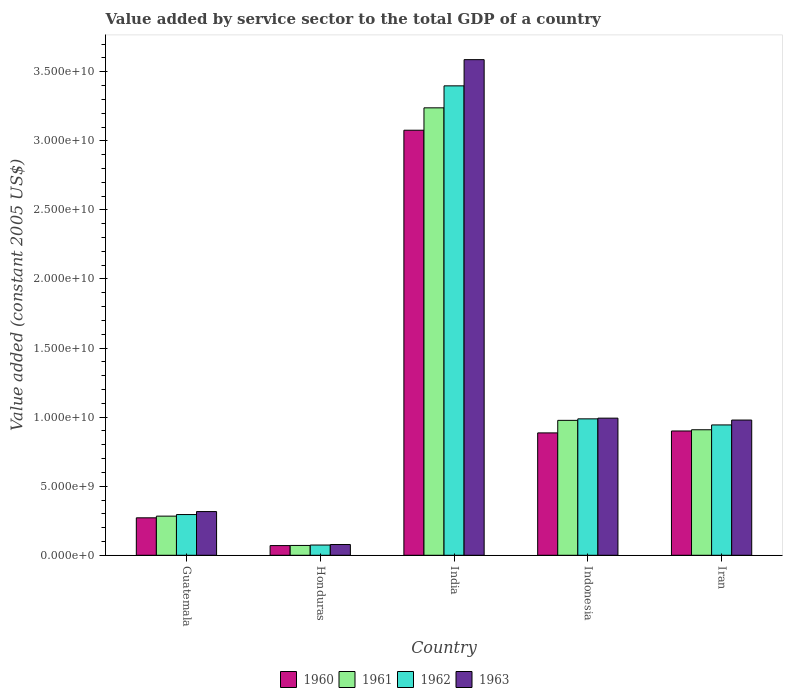How many different coloured bars are there?
Ensure brevity in your answer.  4. How many groups of bars are there?
Give a very brief answer. 5. Are the number of bars per tick equal to the number of legend labels?
Ensure brevity in your answer.  Yes. How many bars are there on the 2nd tick from the right?
Offer a terse response. 4. What is the label of the 5th group of bars from the left?
Provide a succinct answer. Iran. What is the value added by service sector in 1963 in Honduras?
Ensure brevity in your answer.  7.78e+08. Across all countries, what is the maximum value added by service sector in 1963?
Offer a very short reply. 3.59e+1. Across all countries, what is the minimum value added by service sector in 1960?
Offer a terse response. 7.01e+08. In which country was the value added by service sector in 1961 maximum?
Ensure brevity in your answer.  India. In which country was the value added by service sector in 1961 minimum?
Keep it short and to the point. Honduras. What is the total value added by service sector in 1961 in the graph?
Your response must be concise. 5.48e+1. What is the difference between the value added by service sector in 1961 in Indonesia and that in Iran?
Provide a short and direct response. 6.80e+08. What is the difference between the value added by service sector in 1963 in India and the value added by service sector in 1960 in Guatemala?
Ensure brevity in your answer.  3.32e+1. What is the average value added by service sector in 1960 per country?
Your answer should be very brief. 1.04e+1. What is the difference between the value added by service sector of/in 1963 and value added by service sector of/in 1960 in Iran?
Provide a short and direct response. 7.91e+08. What is the ratio of the value added by service sector in 1962 in Guatemala to that in Indonesia?
Offer a very short reply. 0.3. What is the difference between the highest and the second highest value added by service sector in 1961?
Keep it short and to the point. 2.26e+1. What is the difference between the highest and the lowest value added by service sector in 1960?
Ensure brevity in your answer.  3.01e+1. In how many countries, is the value added by service sector in 1961 greater than the average value added by service sector in 1961 taken over all countries?
Give a very brief answer. 1. Is it the case that in every country, the sum of the value added by service sector in 1960 and value added by service sector in 1963 is greater than the sum of value added by service sector in 1961 and value added by service sector in 1962?
Make the answer very short. No. What does the 1st bar from the left in Guatemala represents?
Give a very brief answer. 1960. Are the values on the major ticks of Y-axis written in scientific E-notation?
Offer a terse response. Yes. Does the graph contain any zero values?
Make the answer very short. No. Does the graph contain grids?
Provide a short and direct response. No. Where does the legend appear in the graph?
Offer a very short reply. Bottom center. How are the legend labels stacked?
Your response must be concise. Horizontal. What is the title of the graph?
Your response must be concise. Value added by service sector to the total GDP of a country. What is the label or title of the X-axis?
Your answer should be compact. Country. What is the label or title of the Y-axis?
Make the answer very short. Value added (constant 2005 US$). What is the Value added (constant 2005 US$) of 1960 in Guatemala?
Offer a terse response. 2.71e+09. What is the Value added (constant 2005 US$) of 1961 in Guatemala?
Your answer should be compact. 2.83e+09. What is the Value added (constant 2005 US$) of 1962 in Guatemala?
Your answer should be compact. 2.95e+09. What is the Value added (constant 2005 US$) of 1963 in Guatemala?
Your answer should be compact. 3.16e+09. What is the Value added (constant 2005 US$) in 1960 in Honduras?
Ensure brevity in your answer.  7.01e+08. What is the Value added (constant 2005 US$) of 1961 in Honduras?
Your answer should be compact. 7.12e+08. What is the Value added (constant 2005 US$) of 1962 in Honduras?
Keep it short and to the point. 7.41e+08. What is the Value added (constant 2005 US$) of 1963 in Honduras?
Make the answer very short. 7.78e+08. What is the Value added (constant 2005 US$) of 1960 in India?
Give a very brief answer. 3.08e+1. What is the Value added (constant 2005 US$) of 1961 in India?
Make the answer very short. 3.24e+1. What is the Value added (constant 2005 US$) of 1962 in India?
Provide a short and direct response. 3.40e+1. What is the Value added (constant 2005 US$) of 1963 in India?
Provide a succinct answer. 3.59e+1. What is the Value added (constant 2005 US$) in 1960 in Indonesia?
Offer a terse response. 8.86e+09. What is the Value added (constant 2005 US$) of 1961 in Indonesia?
Keep it short and to the point. 9.77e+09. What is the Value added (constant 2005 US$) of 1962 in Indonesia?
Ensure brevity in your answer.  9.88e+09. What is the Value added (constant 2005 US$) of 1963 in Indonesia?
Offer a very short reply. 9.93e+09. What is the Value added (constant 2005 US$) of 1960 in Iran?
Make the answer very short. 9.00e+09. What is the Value added (constant 2005 US$) in 1961 in Iran?
Offer a terse response. 9.09e+09. What is the Value added (constant 2005 US$) in 1962 in Iran?
Make the answer very short. 9.44e+09. What is the Value added (constant 2005 US$) of 1963 in Iran?
Ensure brevity in your answer.  9.79e+09. Across all countries, what is the maximum Value added (constant 2005 US$) of 1960?
Offer a terse response. 3.08e+1. Across all countries, what is the maximum Value added (constant 2005 US$) in 1961?
Keep it short and to the point. 3.24e+1. Across all countries, what is the maximum Value added (constant 2005 US$) of 1962?
Give a very brief answer. 3.40e+1. Across all countries, what is the maximum Value added (constant 2005 US$) of 1963?
Ensure brevity in your answer.  3.59e+1. Across all countries, what is the minimum Value added (constant 2005 US$) in 1960?
Your answer should be very brief. 7.01e+08. Across all countries, what is the minimum Value added (constant 2005 US$) of 1961?
Give a very brief answer. 7.12e+08. Across all countries, what is the minimum Value added (constant 2005 US$) of 1962?
Provide a short and direct response. 7.41e+08. Across all countries, what is the minimum Value added (constant 2005 US$) of 1963?
Your answer should be compact. 7.78e+08. What is the total Value added (constant 2005 US$) in 1960 in the graph?
Keep it short and to the point. 5.20e+1. What is the total Value added (constant 2005 US$) in 1961 in the graph?
Offer a terse response. 5.48e+1. What is the total Value added (constant 2005 US$) in 1962 in the graph?
Your answer should be very brief. 5.70e+1. What is the total Value added (constant 2005 US$) of 1963 in the graph?
Your answer should be compact. 5.95e+1. What is the difference between the Value added (constant 2005 US$) in 1960 in Guatemala and that in Honduras?
Provide a short and direct response. 2.01e+09. What is the difference between the Value added (constant 2005 US$) in 1961 in Guatemala and that in Honduras?
Offer a terse response. 2.12e+09. What is the difference between the Value added (constant 2005 US$) of 1962 in Guatemala and that in Honduras?
Give a very brief answer. 2.21e+09. What is the difference between the Value added (constant 2005 US$) of 1963 in Guatemala and that in Honduras?
Provide a short and direct response. 2.39e+09. What is the difference between the Value added (constant 2005 US$) in 1960 in Guatemala and that in India?
Make the answer very short. -2.81e+1. What is the difference between the Value added (constant 2005 US$) in 1961 in Guatemala and that in India?
Your response must be concise. -2.96e+1. What is the difference between the Value added (constant 2005 US$) in 1962 in Guatemala and that in India?
Provide a succinct answer. -3.10e+1. What is the difference between the Value added (constant 2005 US$) of 1963 in Guatemala and that in India?
Your response must be concise. -3.27e+1. What is the difference between the Value added (constant 2005 US$) in 1960 in Guatemala and that in Indonesia?
Your answer should be compact. -6.15e+09. What is the difference between the Value added (constant 2005 US$) in 1961 in Guatemala and that in Indonesia?
Provide a succinct answer. -6.93e+09. What is the difference between the Value added (constant 2005 US$) of 1962 in Guatemala and that in Indonesia?
Provide a succinct answer. -6.93e+09. What is the difference between the Value added (constant 2005 US$) in 1963 in Guatemala and that in Indonesia?
Provide a short and direct response. -6.76e+09. What is the difference between the Value added (constant 2005 US$) in 1960 in Guatemala and that in Iran?
Offer a very short reply. -6.29e+09. What is the difference between the Value added (constant 2005 US$) of 1961 in Guatemala and that in Iran?
Provide a short and direct response. -6.25e+09. What is the difference between the Value added (constant 2005 US$) in 1962 in Guatemala and that in Iran?
Your answer should be compact. -6.49e+09. What is the difference between the Value added (constant 2005 US$) of 1963 in Guatemala and that in Iran?
Your answer should be compact. -6.62e+09. What is the difference between the Value added (constant 2005 US$) of 1960 in Honduras and that in India?
Keep it short and to the point. -3.01e+1. What is the difference between the Value added (constant 2005 US$) in 1961 in Honduras and that in India?
Provide a short and direct response. -3.17e+1. What is the difference between the Value added (constant 2005 US$) of 1962 in Honduras and that in India?
Make the answer very short. -3.32e+1. What is the difference between the Value added (constant 2005 US$) of 1963 in Honduras and that in India?
Ensure brevity in your answer.  -3.51e+1. What is the difference between the Value added (constant 2005 US$) in 1960 in Honduras and that in Indonesia?
Make the answer very short. -8.16e+09. What is the difference between the Value added (constant 2005 US$) in 1961 in Honduras and that in Indonesia?
Provide a short and direct response. -9.05e+09. What is the difference between the Value added (constant 2005 US$) of 1962 in Honduras and that in Indonesia?
Give a very brief answer. -9.13e+09. What is the difference between the Value added (constant 2005 US$) of 1963 in Honduras and that in Indonesia?
Make the answer very short. -9.15e+09. What is the difference between the Value added (constant 2005 US$) of 1960 in Honduras and that in Iran?
Your answer should be compact. -8.30e+09. What is the difference between the Value added (constant 2005 US$) in 1961 in Honduras and that in Iran?
Keep it short and to the point. -8.37e+09. What is the difference between the Value added (constant 2005 US$) of 1962 in Honduras and that in Iran?
Your answer should be compact. -8.70e+09. What is the difference between the Value added (constant 2005 US$) in 1963 in Honduras and that in Iran?
Provide a short and direct response. -9.01e+09. What is the difference between the Value added (constant 2005 US$) of 1960 in India and that in Indonesia?
Offer a terse response. 2.19e+1. What is the difference between the Value added (constant 2005 US$) in 1961 in India and that in Indonesia?
Make the answer very short. 2.26e+1. What is the difference between the Value added (constant 2005 US$) in 1962 in India and that in Indonesia?
Offer a very short reply. 2.41e+1. What is the difference between the Value added (constant 2005 US$) in 1963 in India and that in Indonesia?
Offer a very short reply. 2.60e+1. What is the difference between the Value added (constant 2005 US$) in 1960 in India and that in Iran?
Offer a very short reply. 2.18e+1. What is the difference between the Value added (constant 2005 US$) in 1961 in India and that in Iran?
Your response must be concise. 2.33e+1. What is the difference between the Value added (constant 2005 US$) in 1962 in India and that in Iran?
Provide a succinct answer. 2.45e+1. What is the difference between the Value added (constant 2005 US$) in 1963 in India and that in Iran?
Your answer should be compact. 2.61e+1. What is the difference between the Value added (constant 2005 US$) of 1960 in Indonesia and that in Iran?
Keep it short and to the point. -1.39e+08. What is the difference between the Value added (constant 2005 US$) in 1961 in Indonesia and that in Iran?
Ensure brevity in your answer.  6.80e+08. What is the difference between the Value added (constant 2005 US$) in 1962 in Indonesia and that in Iran?
Give a very brief answer. 4.39e+08. What is the difference between the Value added (constant 2005 US$) in 1963 in Indonesia and that in Iran?
Keep it short and to the point. 1.38e+08. What is the difference between the Value added (constant 2005 US$) of 1960 in Guatemala and the Value added (constant 2005 US$) of 1961 in Honduras?
Keep it short and to the point. 2.00e+09. What is the difference between the Value added (constant 2005 US$) of 1960 in Guatemala and the Value added (constant 2005 US$) of 1962 in Honduras?
Provide a succinct answer. 1.97e+09. What is the difference between the Value added (constant 2005 US$) of 1960 in Guatemala and the Value added (constant 2005 US$) of 1963 in Honduras?
Ensure brevity in your answer.  1.93e+09. What is the difference between the Value added (constant 2005 US$) of 1961 in Guatemala and the Value added (constant 2005 US$) of 1962 in Honduras?
Your response must be concise. 2.09e+09. What is the difference between the Value added (constant 2005 US$) of 1961 in Guatemala and the Value added (constant 2005 US$) of 1963 in Honduras?
Keep it short and to the point. 2.06e+09. What is the difference between the Value added (constant 2005 US$) of 1962 in Guatemala and the Value added (constant 2005 US$) of 1963 in Honduras?
Your answer should be very brief. 2.17e+09. What is the difference between the Value added (constant 2005 US$) of 1960 in Guatemala and the Value added (constant 2005 US$) of 1961 in India?
Provide a short and direct response. -2.97e+1. What is the difference between the Value added (constant 2005 US$) in 1960 in Guatemala and the Value added (constant 2005 US$) in 1962 in India?
Offer a very short reply. -3.13e+1. What is the difference between the Value added (constant 2005 US$) of 1960 in Guatemala and the Value added (constant 2005 US$) of 1963 in India?
Your answer should be very brief. -3.32e+1. What is the difference between the Value added (constant 2005 US$) in 1961 in Guatemala and the Value added (constant 2005 US$) in 1962 in India?
Your answer should be very brief. -3.11e+1. What is the difference between the Value added (constant 2005 US$) of 1961 in Guatemala and the Value added (constant 2005 US$) of 1963 in India?
Ensure brevity in your answer.  -3.30e+1. What is the difference between the Value added (constant 2005 US$) of 1962 in Guatemala and the Value added (constant 2005 US$) of 1963 in India?
Your answer should be very brief. -3.29e+1. What is the difference between the Value added (constant 2005 US$) of 1960 in Guatemala and the Value added (constant 2005 US$) of 1961 in Indonesia?
Offer a very short reply. -7.05e+09. What is the difference between the Value added (constant 2005 US$) in 1960 in Guatemala and the Value added (constant 2005 US$) in 1962 in Indonesia?
Give a very brief answer. -7.16e+09. What is the difference between the Value added (constant 2005 US$) in 1960 in Guatemala and the Value added (constant 2005 US$) in 1963 in Indonesia?
Offer a very short reply. -7.21e+09. What is the difference between the Value added (constant 2005 US$) in 1961 in Guatemala and the Value added (constant 2005 US$) in 1962 in Indonesia?
Make the answer very short. -7.04e+09. What is the difference between the Value added (constant 2005 US$) of 1961 in Guatemala and the Value added (constant 2005 US$) of 1963 in Indonesia?
Make the answer very short. -7.09e+09. What is the difference between the Value added (constant 2005 US$) in 1962 in Guatemala and the Value added (constant 2005 US$) in 1963 in Indonesia?
Provide a succinct answer. -6.98e+09. What is the difference between the Value added (constant 2005 US$) of 1960 in Guatemala and the Value added (constant 2005 US$) of 1961 in Iran?
Your response must be concise. -6.37e+09. What is the difference between the Value added (constant 2005 US$) in 1960 in Guatemala and the Value added (constant 2005 US$) in 1962 in Iran?
Provide a succinct answer. -6.72e+09. What is the difference between the Value added (constant 2005 US$) of 1960 in Guatemala and the Value added (constant 2005 US$) of 1963 in Iran?
Ensure brevity in your answer.  -7.08e+09. What is the difference between the Value added (constant 2005 US$) in 1961 in Guatemala and the Value added (constant 2005 US$) in 1962 in Iran?
Offer a terse response. -6.60e+09. What is the difference between the Value added (constant 2005 US$) in 1961 in Guatemala and the Value added (constant 2005 US$) in 1963 in Iran?
Ensure brevity in your answer.  -6.95e+09. What is the difference between the Value added (constant 2005 US$) of 1962 in Guatemala and the Value added (constant 2005 US$) of 1963 in Iran?
Make the answer very short. -6.84e+09. What is the difference between the Value added (constant 2005 US$) in 1960 in Honduras and the Value added (constant 2005 US$) in 1961 in India?
Provide a succinct answer. -3.17e+1. What is the difference between the Value added (constant 2005 US$) in 1960 in Honduras and the Value added (constant 2005 US$) in 1962 in India?
Your answer should be compact. -3.33e+1. What is the difference between the Value added (constant 2005 US$) of 1960 in Honduras and the Value added (constant 2005 US$) of 1963 in India?
Your answer should be very brief. -3.52e+1. What is the difference between the Value added (constant 2005 US$) of 1961 in Honduras and the Value added (constant 2005 US$) of 1962 in India?
Ensure brevity in your answer.  -3.33e+1. What is the difference between the Value added (constant 2005 US$) of 1961 in Honduras and the Value added (constant 2005 US$) of 1963 in India?
Ensure brevity in your answer.  -3.52e+1. What is the difference between the Value added (constant 2005 US$) in 1962 in Honduras and the Value added (constant 2005 US$) in 1963 in India?
Your answer should be very brief. -3.51e+1. What is the difference between the Value added (constant 2005 US$) of 1960 in Honduras and the Value added (constant 2005 US$) of 1961 in Indonesia?
Ensure brevity in your answer.  -9.07e+09. What is the difference between the Value added (constant 2005 US$) in 1960 in Honduras and the Value added (constant 2005 US$) in 1962 in Indonesia?
Your answer should be very brief. -9.17e+09. What is the difference between the Value added (constant 2005 US$) of 1960 in Honduras and the Value added (constant 2005 US$) of 1963 in Indonesia?
Your answer should be compact. -9.23e+09. What is the difference between the Value added (constant 2005 US$) of 1961 in Honduras and the Value added (constant 2005 US$) of 1962 in Indonesia?
Your response must be concise. -9.16e+09. What is the difference between the Value added (constant 2005 US$) in 1961 in Honduras and the Value added (constant 2005 US$) in 1963 in Indonesia?
Your response must be concise. -9.22e+09. What is the difference between the Value added (constant 2005 US$) of 1962 in Honduras and the Value added (constant 2005 US$) of 1963 in Indonesia?
Keep it short and to the point. -9.19e+09. What is the difference between the Value added (constant 2005 US$) in 1960 in Honduras and the Value added (constant 2005 US$) in 1961 in Iran?
Make the answer very short. -8.39e+09. What is the difference between the Value added (constant 2005 US$) in 1960 in Honduras and the Value added (constant 2005 US$) in 1962 in Iran?
Offer a terse response. -8.73e+09. What is the difference between the Value added (constant 2005 US$) of 1960 in Honduras and the Value added (constant 2005 US$) of 1963 in Iran?
Your answer should be very brief. -9.09e+09. What is the difference between the Value added (constant 2005 US$) of 1961 in Honduras and the Value added (constant 2005 US$) of 1962 in Iran?
Offer a terse response. -8.72e+09. What is the difference between the Value added (constant 2005 US$) of 1961 in Honduras and the Value added (constant 2005 US$) of 1963 in Iran?
Provide a succinct answer. -9.08e+09. What is the difference between the Value added (constant 2005 US$) of 1962 in Honduras and the Value added (constant 2005 US$) of 1963 in Iran?
Your answer should be compact. -9.05e+09. What is the difference between the Value added (constant 2005 US$) of 1960 in India and the Value added (constant 2005 US$) of 1961 in Indonesia?
Keep it short and to the point. 2.10e+1. What is the difference between the Value added (constant 2005 US$) of 1960 in India and the Value added (constant 2005 US$) of 1962 in Indonesia?
Offer a terse response. 2.09e+1. What is the difference between the Value added (constant 2005 US$) of 1960 in India and the Value added (constant 2005 US$) of 1963 in Indonesia?
Keep it short and to the point. 2.08e+1. What is the difference between the Value added (constant 2005 US$) in 1961 in India and the Value added (constant 2005 US$) in 1962 in Indonesia?
Offer a terse response. 2.25e+1. What is the difference between the Value added (constant 2005 US$) of 1961 in India and the Value added (constant 2005 US$) of 1963 in Indonesia?
Offer a terse response. 2.25e+1. What is the difference between the Value added (constant 2005 US$) in 1962 in India and the Value added (constant 2005 US$) in 1963 in Indonesia?
Provide a succinct answer. 2.41e+1. What is the difference between the Value added (constant 2005 US$) in 1960 in India and the Value added (constant 2005 US$) in 1961 in Iran?
Your answer should be very brief. 2.17e+1. What is the difference between the Value added (constant 2005 US$) of 1960 in India and the Value added (constant 2005 US$) of 1962 in Iran?
Give a very brief answer. 2.13e+1. What is the difference between the Value added (constant 2005 US$) of 1960 in India and the Value added (constant 2005 US$) of 1963 in Iran?
Ensure brevity in your answer.  2.10e+1. What is the difference between the Value added (constant 2005 US$) in 1961 in India and the Value added (constant 2005 US$) in 1962 in Iran?
Make the answer very short. 2.30e+1. What is the difference between the Value added (constant 2005 US$) of 1961 in India and the Value added (constant 2005 US$) of 1963 in Iran?
Ensure brevity in your answer.  2.26e+1. What is the difference between the Value added (constant 2005 US$) of 1962 in India and the Value added (constant 2005 US$) of 1963 in Iran?
Your answer should be very brief. 2.42e+1. What is the difference between the Value added (constant 2005 US$) of 1960 in Indonesia and the Value added (constant 2005 US$) of 1961 in Iran?
Keep it short and to the point. -2.28e+08. What is the difference between the Value added (constant 2005 US$) of 1960 in Indonesia and the Value added (constant 2005 US$) of 1962 in Iran?
Keep it short and to the point. -5.77e+08. What is the difference between the Value added (constant 2005 US$) in 1960 in Indonesia and the Value added (constant 2005 US$) in 1963 in Iran?
Offer a very short reply. -9.30e+08. What is the difference between the Value added (constant 2005 US$) in 1961 in Indonesia and the Value added (constant 2005 US$) in 1962 in Iran?
Offer a terse response. 3.30e+08. What is the difference between the Value added (constant 2005 US$) in 1961 in Indonesia and the Value added (constant 2005 US$) in 1963 in Iran?
Offer a very short reply. -2.20e+07. What is the difference between the Value added (constant 2005 US$) of 1962 in Indonesia and the Value added (constant 2005 US$) of 1963 in Iran?
Provide a succinct answer. 8.67e+07. What is the average Value added (constant 2005 US$) in 1960 per country?
Give a very brief answer. 1.04e+1. What is the average Value added (constant 2005 US$) in 1961 per country?
Give a very brief answer. 1.10e+1. What is the average Value added (constant 2005 US$) in 1962 per country?
Your answer should be very brief. 1.14e+1. What is the average Value added (constant 2005 US$) in 1963 per country?
Your answer should be compact. 1.19e+1. What is the difference between the Value added (constant 2005 US$) in 1960 and Value added (constant 2005 US$) in 1961 in Guatemala?
Give a very brief answer. -1.22e+08. What is the difference between the Value added (constant 2005 US$) in 1960 and Value added (constant 2005 US$) in 1962 in Guatemala?
Ensure brevity in your answer.  -2.35e+08. What is the difference between the Value added (constant 2005 US$) of 1960 and Value added (constant 2005 US$) of 1963 in Guatemala?
Provide a short and direct response. -4.53e+08. What is the difference between the Value added (constant 2005 US$) of 1961 and Value added (constant 2005 US$) of 1962 in Guatemala?
Provide a succinct answer. -1.14e+08. What is the difference between the Value added (constant 2005 US$) in 1961 and Value added (constant 2005 US$) in 1963 in Guatemala?
Your answer should be compact. -3.31e+08. What is the difference between the Value added (constant 2005 US$) in 1962 and Value added (constant 2005 US$) in 1963 in Guatemala?
Your response must be concise. -2.17e+08. What is the difference between the Value added (constant 2005 US$) of 1960 and Value added (constant 2005 US$) of 1961 in Honduras?
Provide a succinct answer. -1.04e+07. What is the difference between the Value added (constant 2005 US$) of 1960 and Value added (constant 2005 US$) of 1962 in Honduras?
Keep it short and to the point. -3.93e+07. What is the difference between the Value added (constant 2005 US$) of 1960 and Value added (constant 2005 US$) of 1963 in Honduras?
Provide a short and direct response. -7.65e+07. What is the difference between the Value added (constant 2005 US$) in 1961 and Value added (constant 2005 US$) in 1962 in Honduras?
Give a very brief answer. -2.89e+07. What is the difference between the Value added (constant 2005 US$) in 1961 and Value added (constant 2005 US$) in 1963 in Honduras?
Provide a succinct answer. -6.62e+07. What is the difference between the Value added (constant 2005 US$) of 1962 and Value added (constant 2005 US$) of 1963 in Honduras?
Ensure brevity in your answer.  -3.72e+07. What is the difference between the Value added (constant 2005 US$) in 1960 and Value added (constant 2005 US$) in 1961 in India?
Offer a terse response. -1.62e+09. What is the difference between the Value added (constant 2005 US$) in 1960 and Value added (constant 2005 US$) in 1962 in India?
Ensure brevity in your answer.  -3.21e+09. What is the difference between the Value added (constant 2005 US$) of 1960 and Value added (constant 2005 US$) of 1963 in India?
Your answer should be compact. -5.11e+09. What is the difference between the Value added (constant 2005 US$) of 1961 and Value added (constant 2005 US$) of 1962 in India?
Your answer should be compact. -1.59e+09. What is the difference between the Value added (constant 2005 US$) in 1961 and Value added (constant 2005 US$) in 1963 in India?
Make the answer very short. -3.49e+09. What is the difference between the Value added (constant 2005 US$) in 1962 and Value added (constant 2005 US$) in 1963 in India?
Offer a very short reply. -1.90e+09. What is the difference between the Value added (constant 2005 US$) in 1960 and Value added (constant 2005 US$) in 1961 in Indonesia?
Offer a terse response. -9.08e+08. What is the difference between the Value added (constant 2005 US$) of 1960 and Value added (constant 2005 US$) of 1962 in Indonesia?
Provide a succinct answer. -1.02e+09. What is the difference between the Value added (constant 2005 US$) of 1960 and Value added (constant 2005 US$) of 1963 in Indonesia?
Keep it short and to the point. -1.07e+09. What is the difference between the Value added (constant 2005 US$) in 1961 and Value added (constant 2005 US$) in 1962 in Indonesia?
Give a very brief answer. -1.09e+08. What is the difference between the Value added (constant 2005 US$) in 1961 and Value added (constant 2005 US$) in 1963 in Indonesia?
Ensure brevity in your answer.  -1.60e+08. What is the difference between the Value added (constant 2005 US$) of 1962 and Value added (constant 2005 US$) of 1963 in Indonesia?
Your response must be concise. -5.15e+07. What is the difference between the Value added (constant 2005 US$) of 1960 and Value added (constant 2005 US$) of 1961 in Iran?
Provide a short and direct response. -8.88e+07. What is the difference between the Value added (constant 2005 US$) of 1960 and Value added (constant 2005 US$) of 1962 in Iran?
Make the answer very short. -4.39e+08. What is the difference between the Value added (constant 2005 US$) in 1960 and Value added (constant 2005 US$) in 1963 in Iran?
Your answer should be compact. -7.91e+08. What is the difference between the Value added (constant 2005 US$) of 1961 and Value added (constant 2005 US$) of 1962 in Iran?
Provide a short and direct response. -3.50e+08. What is the difference between the Value added (constant 2005 US$) in 1961 and Value added (constant 2005 US$) in 1963 in Iran?
Offer a very short reply. -7.02e+08. What is the difference between the Value added (constant 2005 US$) of 1962 and Value added (constant 2005 US$) of 1963 in Iran?
Provide a short and direct response. -3.52e+08. What is the ratio of the Value added (constant 2005 US$) of 1960 in Guatemala to that in Honduras?
Offer a very short reply. 3.87. What is the ratio of the Value added (constant 2005 US$) of 1961 in Guatemala to that in Honduras?
Keep it short and to the point. 3.98. What is the ratio of the Value added (constant 2005 US$) in 1962 in Guatemala to that in Honduras?
Provide a succinct answer. 3.98. What is the ratio of the Value added (constant 2005 US$) of 1963 in Guatemala to that in Honduras?
Your response must be concise. 4.07. What is the ratio of the Value added (constant 2005 US$) of 1960 in Guatemala to that in India?
Provide a succinct answer. 0.09. What is the ratio of the Value added (constant 2005 US$) in 1961 in Guatemala to that in India?
Your answer should be very brief. 0.09. What is the ratio of the Value added (constant 2005 US$) in 1962 in Guatemala to that in India?
Provide a succinct answer. 0.09. What is the ratio of the Value added (constant 2005 US$) in 1963 in Guatemala to that in India?
Your answer should be very brief. 0.09. What is the ratio of the Value added (constant 2005 US$) of 1960 in Guatemala to that in Indonesia?
Provide a short and direct response. 0.31. What is the ratio of the Value added (constant 2005 US$) of 1961 in Guatemala to that in Indonesia?
Your answer should be compact. 0.29. What is the ratio of the Value added (constant 2005 US$) in 1962 in Guatemala to that in Indonesia?
Your answer should be compact. 0.3. What is the ratio of the Value added (constant 2005 US$) in 1963 in Guatemala to that in Indonesia?
Make the answer very short. 0.32. What is the ratio of the Value added (constant 2005 US$) of 1960 in Guatemala to that in Iran?
Provide a short and direct response. 0.3. What is the ratio of the Value added (constant 2005 US$) in 1961 in Guatemala to that in Iran?
Offer a terse response. 0.31. What is the ratio of the Value added (constant 2005 US$) of 1962 in Guatemala to that in Iran?
Offer a very short reply. 0.31. What is the ratio of the Value added (constant 2005 US$) in 1963 in Guatemala to that in Iran?
Ensure brevity in your answer.  0.32. What is the ratio of the Value added (constant 2005 US$) of 1960 in Honduras to that in India?
Offer a very short reply. 0.02. What is the ratio of the Value added (constant 2005 US$) in 1961 in Honduras to that in India?
Offer a terse response. 0.02. What is the ratio of the Value added (constant 2005 US$) in 1962 in Honduras to that in India?
Offer a terse response. 0.02. What is the ratio of the Value added (constant 2005 US$) of 1963 in Honduras to that in India?
Provide a short and direct response. 0.02. What is the ratio of the Value added (constant 2005 US$) in 1960 in Honduras to that in Indonesia?
Give a very brief answer. 0.08. What is the ratio of the Value added (constant 2005 US$) in 1961 in Honduras to that in Indonesia?
Give a very brief answer. 0.07. What is the ratio of the Value added (constant 2005 US$) of 1962 in Honduras to that in Indonesia?
Provide a succinct answer. 0.07. What is the ratio of the Value added (constant 2005 US$) in 1963 in Honduras to that in Indonesia?
Ensure brevity in your answer.  0.08. What is the ratio of the Value added (constant 2005 US$) in 1960 in Honduras to that in Iran?
Keep it short and to the point. 0.08. What is the ratio of the Value added (constant 2005 US$) of 1961 in Honduras to that in Iran?
Give a very brief answer. 0.08. What is the ratio of the Value added (constant 2005 US$) of 1962 in Honduras to that in Iran?
Offer a very short reply. 0.08. What is the ratio of the Value added (constant 2005 US$) of 1963 in Honduras to that in Iran?
Offer a terse response. 0.08. What is the ratio of the Value added (constant 2005 US$) in 1960 in India to that in Indonesia?
Keep it short and to the point. 3.47. What is the ratio of the Value added (constant 2005 US$) of 1961 in India to that in Indonesia?
Your answer should be very brief. 3.32. What is the ratio of the Value added (constant 2005 US$) in 1962 in India to that in Indonesia?
Offer a very short reply. 3.44. What is the ratio of the Value added (constant 2005 US$) in 1963 in India to that in Indonesia?
Give a very brief answer. 3.61. What is the ratio of the Value added (constant 2005 US$) in 1960 in India to that in Iran?
Keep it short and to the point. 3.42. What is the ratio of the Value added (constant 2005 US$) of 1961 in India to that in Iran?
Your answer should be compact. 3.56. What is the ratio of the Value added (constant 2005 US$) of 1962 in India to that in Iran?
Provide a succinct answer. 3.6. What is the ratio of the Value added (constant 2005 US$) of 1963 in India to that in Iran?
Offer a terse response. 3.67. What is the ratio of the Value added (constant 2005 US$) in 1960 in Indonesia to that in Iran?
Make the answer very short. 0.98. What is the ratio of the Value added (constant 2005 US$) in 1961 in Indonesia to that in Iran?
Make the answer very short. 1.07. What is the ratio of the Value added (constant 2005 US$) of 1962 in Indonesia to that in Iran?
Keep it short and to the point. 1.05. What is the ratio of the Value added (constant 2005 US$) of 1963 in Indonesia to that in Iran?
Your answer should be compact. 1.01. What is the difference between the highest and the second highest Value added (constant 2005 US$) of 1960?
Your response must be concise. 2.18e+1. What is the difference between the highest and the second highest Value added (constant 2005 US$) in 1961?
Provide a succinct answer. 2.26e+1. What is the difference between the highest and the second highest Value added (constant 2005 US$) of 1962?
Provide a succinct answer. 2.41e+1. What is the difference between the highest and the second highest Value added (constant 2005 US$) of 1963?
Offer a very short reply. 2.60e+1. What is the difference between the highest and the lowest Value added (constant 2005 US$) in 1960?
Provide a succinct answer. 3.01e+1. What is the difference between the highest and the lowest Value added (constant 2005 US$) of 1961?
Offer a terse response. 3.17e+1. What is the difference between the highest and the lowest Value added (constant 2005 US$) of 1962?
Make the answer very short. 3.32e+1. What is the difference between the highest and the lowest Value added (constant 2005 US$) of 1963?
Your response must be concise. 3.51e+1. 